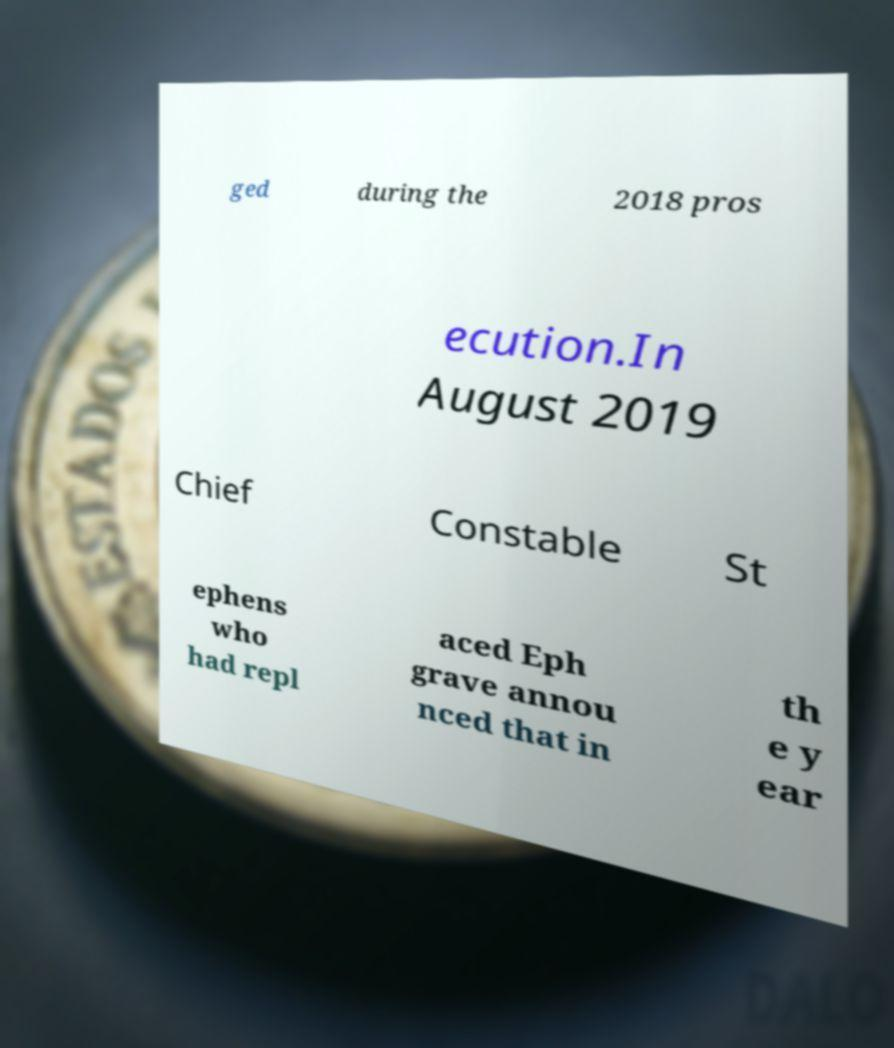Could you extract and type out the text from this image? ged during the 2018 pros ecution.In August 2019 Chief Constable St ephens who had repl aced Eph grave annou nced that in th e y ear 